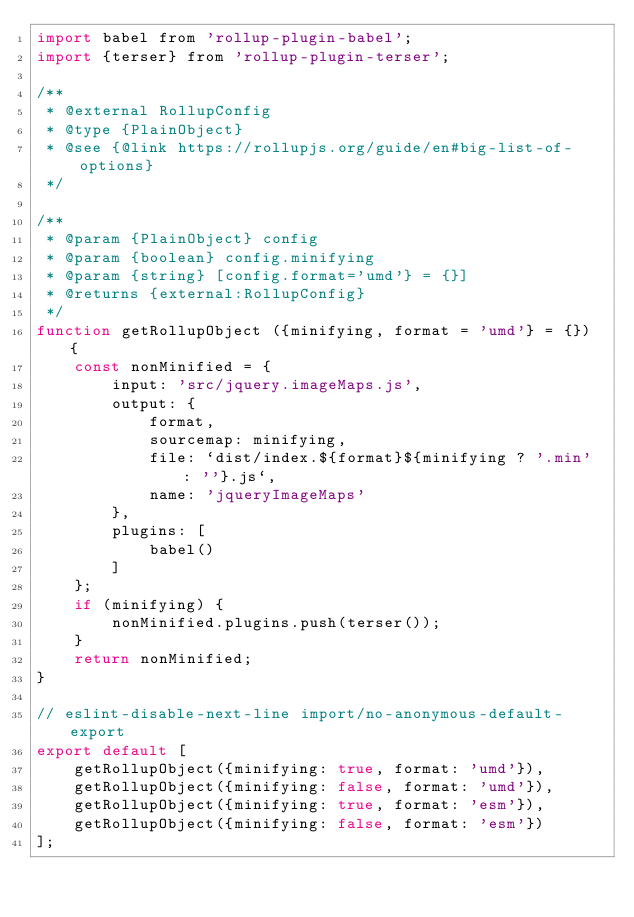Convert code to text. <code><loc_0><loc_0><loc_500><loc_500><_JavaScript_>import babel from 'rollup-plugin-babel';
import {terser} from 'rollup-plugin-terser';

/**
 * @external RollupConfig
 * @type {PlainObject}
 * @see {@link https://rollupjs.org/guide/en#big-list-of-options}
 */

/**
 * @param {PlainObject} config
 * @param {boolean} config.minifying
 * @param {string} [config.format='umd'} = {}]
 * @returns {external:RollupConfig}
 */
function getRollupObject ({minifying, format = 'umd'} = {}) {
    const nonMinified = {
        input: 'src/jquery.imageMaps.js',
        output: {
            format,
            sourcemap: minifying,
            file: `dist/index.${format}${minifying ? '.min' : ''}.js`,
            name: 'jqueryImageMaps'
        },
        plugins: [
            babel()
        ]
    };
    if (minifying) {
        nonMinified.plugins.push(terser());
    }
    return nonMinified;
}

// eslint-disable-next-line import/no-anonymous-default-export
export default [
    getRollupObject({minifying: true, format: 'umd'}),
    getRollupObject({minifying: false, format: 'umd'}),
    getRollupObject({minifying: true, format: 'esm'}),
    getRollupObject({minifying: false, format: 'esm'})
];
</code> 